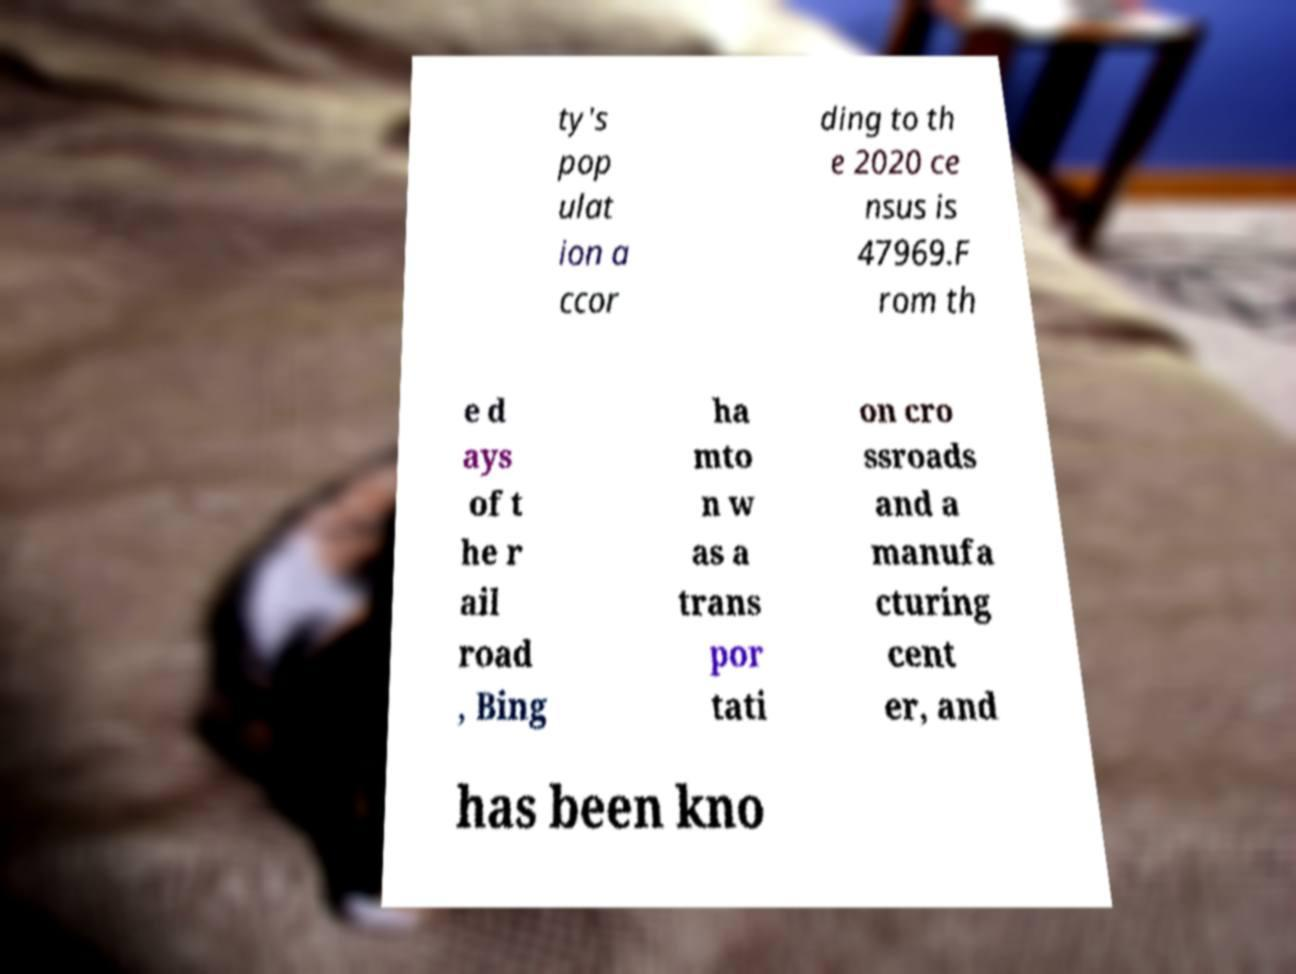Could you assist in decoding the text presented in this image and type it out clearly? ty's pop ulat ion a ccor ding to th e 2020 ce nsus is 47969.F rom th e d ays of t he r ail road , Bing ha mto n w as a trans por tati on cro ssroads and a manufa cturing cent er, and has been kno 